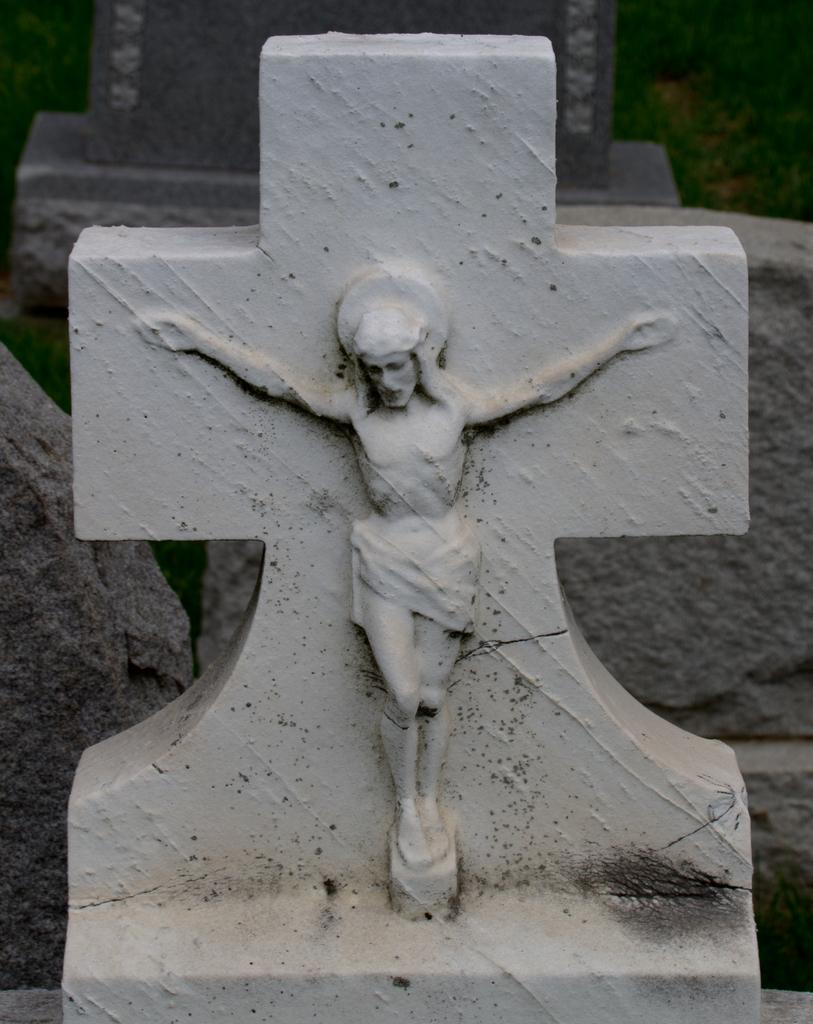What is the main subject of the image? There is a Jesus sculpture on a cross symbol in the image. What can be seen in the background of the image? There are rocks visible in the background of the image. What type of suit is the Jesus sculpture wearing in the image? The Jesus sculpture is a sculpture and does not wear clothing, so there is no suit present in the image. 